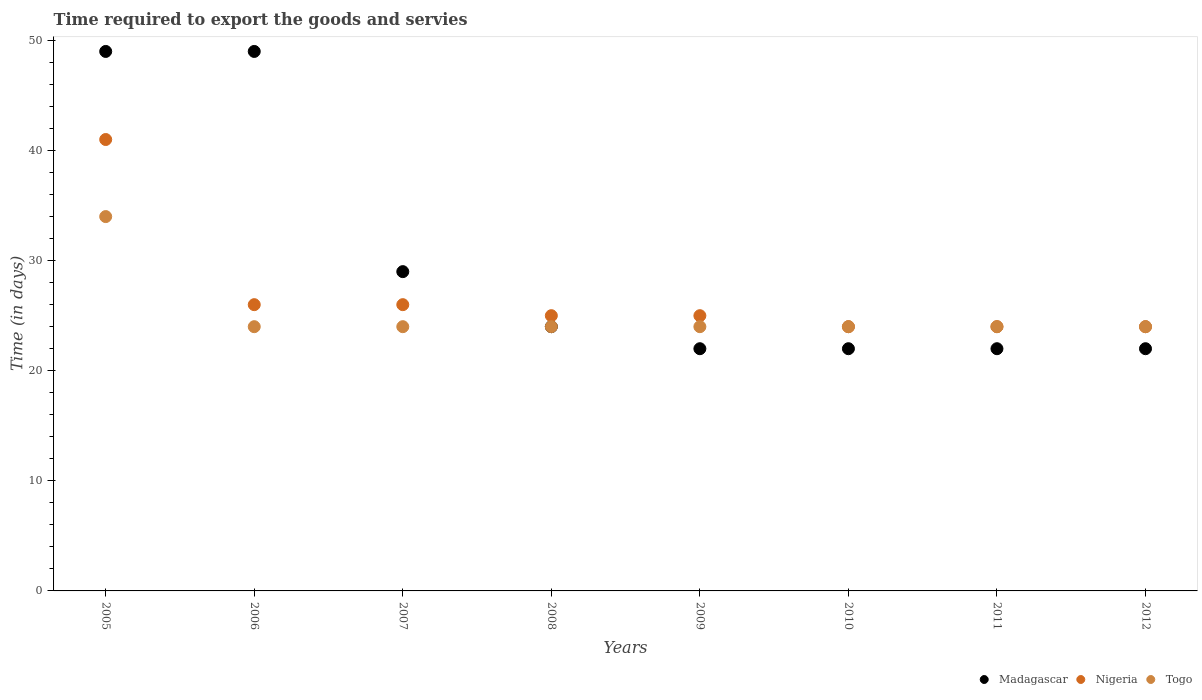How many different coloured dotlines are there?
Your answer should be very brief. 3. Is the number of dotlines equal to the number of legend labels?
Make the answer very short. Yes. What is the number of days required to export the goods and services in Togo in 2009?
Make the answer very short. 24. Across all years, what is the minimum number of days required to export the goods and services in Madagascar?
Give a very brief answer. 22. In which year was the number of days required to export the goods and services in Madagascar maximum?
Make the answer very short. 2005. In which year was the number of days required to export the goods and services in Nigeria minimum?
Offer a terse response. 2010. What is the total number of days required to export the goods and services in Togo in the graph?
Give a very brief answer. 202. What is the difference between the number of days required to export the goods and services in Nigeria in 2005 and that in 2008?
Give a very brief answer. 16. What is the average number of days required to export the goods and services in Madagascar per year?
Offer a very short reply. 29.88. Is the difference between the number of days required to export the goods and services in Nigeria in 2009 and 2011 greater than the difference between the number of days required to export the goods and services in Togo in 2009 and 2011?
Your answer should be compact. Yes. What is the difference between the highest and the second highest number of days required to export the goods and services in Madagascar?
Your answer should be compact. 0. What is the difference between the highest and the lowest number of days required to export the goods and services in Togo?
Offer a terse response. 10. In how many years, is the number of days required to export the goods and services in Nigeria greater than the average number of days required to export the goods and services in Nigeria taken over all years?
Your answer should be compact. 1. Is the sum of the number of days required to export the goods and services in Togo in 2006 and 2010 greater than the maximum number of days required to export the goods and services in Madagascar across all years?
Keep it short and to the point. No. Is it the case that in every year, the sum of the number of days required to export the goods and services in Togo and number of days required to export the goods and services in Nigeria  is greater than the number of days required to export the goods and services in Madagascar?
Offer a very short reply. Yes. Is the number of days required to export the goods and services in Nigeria strictly less than the number of days required to export the goods and services in Madagascar over the years?
Your response must be concise. No. How many years are there in the graph?
Make the answer very short. 8. Are the values on the major ticks of Y-axis written in scientific E-notation?
Offer a terse response. No. Does the graph contain grids?
Make the answer very short. No. What is the title of the graph?
Offer a terse response. Time required to export the goods and servies. What is the label or title of the Y-axis?
Keep it short and to the point. Time (in days). What is the Time (in days) in Nigeria in 2005?
Your response must be concise. 41. What is the Time (in days) of Togo in 2005?
Your answer should be compact. 34. What is the Time (in days) in Madagascar in 2006?
Offer a terse response. 49. What is the Time (in days) of Nigeria in 2006?
Your answer should be very brief. 26. What is the Time (in days) of Togo in 2006?
Provide a short and direct response. 24. What is the Time (in days) of Madagascar in 2007?
Your response must be concise. 29. What is the Time (in days) in Nigeria in 2007?
Make the answer very short. 26. What is the Time (in days) in Madagascar in 2008?
Ensure brevity in your answer.  24. What is the Time (in days) in Nigeria in 2008?
Ensure brevity in your answer.  25. What is the Time (in days) in Togo in 2008?
Your response must be concise. 24. What is the Time (in days) in Nigeria in 2010?
Offer a terse response. 24. What is the Time (in days) in Togo in 2010?
Offer a very short reply. 24. What is the Time (in days) in Madagascar in 2011?
Offer a very short reply. 22. What is the Time (in days) in Togo in 2012?
Provide a succinct answer. 24. Across all years, what is the maximum Time (in days) of Madagascar?
Your answer should be compact. 49. Across all years, what is the maximum Time (in days) in Nigeria?
Your response must be concise. 41. Across all years, what is the maximum Time (in days) in Togo?
Offer a very short reply. 34. Across all years, what is the minimum Time (in days) in Togo?
Your response must be concise. 24. What is the total Time (in days) in Madagascar in the graph?
Give a very brief answer. 239. What is the total Time (in days) in Nigeria in the graph?
Your response must be concise. 215. What is the total Time (in days) of Togo in the graph?
Ensure brevity in your answer.  202. What is the difference between the Time (in days) in Madagascar in 2005 and that in 2006?
Keep it short and to the point. 0. What is the difference between the Time (in days) of Nigeria in 2005 and that in 2006?
Your response must be concise. 15. What is the difference between the Time (in days) of Togo in 2005 and that in 2007?
Ensure brevity in your answer.  10. What is the difference between the Time (in days) in Nigeria in 2005 and that in 2009?
Provide a short and direct response. 16. What is the difference between the Time (in days) of Togo in 2005 and that in 2010?
Offer a terse response. 10. What is the difference between the Time (in days) in Madagascar in 2005 and that in 2011?
Ensure brevity in your answer.  27. What is the difference between the Time (in days) in Nigeria in 2005 and that in 2011?
Make the answer very short. 17. What is the difference between the Time (in days) in Madagascar in 2005 and that in 2012?
Provide a succinct answer. 27. What is the difference between the Time (in days) of Togo in 2005 and that in 2012?
Provide a succinct answer. 10. What is the difference between the Time (in days) of Madagascar in 2006 and that in 2007?
Ensure brevity in your answer.  20. What is the difference between the Time (in days) in Togo in 2006 and that in 2008?
Keep it short and to the point. 0. What is the difference between the Time (in days) of Nigeria in 2006 and that in 2009?
Keep it short and to the point. 1. What is the difference between the Time (in days) of Togo in 2006 and that in 2009?
Offer a very short reply. 0. What is the difference between the Time (in days) of Togo in 2006 and that in 2010?
Offer a very short reply. 0. What is the difference between the Time (in days) of Madagascar in 2006 and that in 2011?
Provide a succinct answer. 27. What is the difference between the Time (in days) in Nigeria in 2006 and that in 2011?
Give a very brief answer. 2. What is the difference between the Time (in days) in Madagascar in 2006 and that in 2012?
Keep it short and to the point. 27. What is the difference between the Time (in days) of Nigeria in 2007 and that in 2008?
Provide a short and direct response. 1. What is the difference between the Time (in days) of Togo in 2007 and that in 2008?
Keep it short and to the point. 0. What is the difference between the Time (in days) of Madagascar in 2007 and that in 2011?
Keep it short and to the point. 7. What is the difference between the Time (in days) of Togo in 2007 and that in 2011?
Your answer should be very brief. 0. What is the difference between the Time (in days) of Nigeria in 2007 and that in 2012?
Ensure brevity in your answer.  2. What is the difference between the Time (in days) in Madagascar in 2008 and that in 2009?
Keep it short and to the point. 2. What is the difference between the Time (in days) in Togo in 2008 and that in 2012?
Offer a very short reply. 0. What is the difference between the Time (in days) of Madagascar in 2009 and that in 2010?
Ensure brevity in your answer.  0. What is the difference between the Time (in days) of Togo in 2009 and that in 2010?
Offer a terse response. 0. What is the difference between the Time (in days) in Madagascar in 2009 and that in 2012?
Ensure brevity in your answer.  0. What is the difference between the Time (in days) in Togo in 2009 and that in 2012?
Provide a short and direct response. 0. What is the difference between the Time (in days) of Madagascar in 2010 and that in 2011?
Your response must be concise. 0. What is the difference between the Time (in days) in Nigeria in 2010 and that in 2011?
Your answer should be compact. 0. What is the difference between the Time (in days) of Togo in 2010 and that in 2011?
Offer a terse response. 0. What is the difference between the Time (in days) of Nigeria in 2010 and that in 2012?
Keep it short and to the point. 0. What is the difference between the Time (in days) of Madagascar in 2011 and that in 2012?
Your response must be concise. 0. What is the difference between the Time (in days) in Nigeria in 2011 and that in 2012?
Your answer should be very brief. 0. What is the difference between the Time (in days) of Togo in 2011 and that in 2012?
Ensure brevity in your answer.  0. What is the difference between the Time (in days) in Madagascar in 2005 and the Time (in days) in Nigeria in 2006?
Provide a succinct answer. 23. What is the difference between the Time (in days) of Nigeria in 2005 and the Time (in days) of Togo in 2006?
Provide a short and direct response. 17. What is the difference between the Time (in days) in Nigeria in 2005 and the Time (in days) in Togo in 2007?
Keep it short and to the point. 17. What is the difference between the Time (in days) in Madagascar in 2005 and the Time (in days) in Nigeria in 2008?
Keep it short and to the point. 24. What is the difference between the Time (in days) in Madagascar in 2005 and the Time (in days) in Togo in 2008?
Make the answer very short. 25. What is the difference between the Time (in days) of Madagascar in 2005 and the Time (in days) of Togo in 2009?
Your answer should be very brief. 25. What is the difference between the Time (in days) of Madagascar in 2005 and the Time (in days) of Nigeria in 2010?
Your response must be concise. 25. What is the difference between the Time (in days) of Madagascar in 2005 and the Time (in days) of Togo in 2010?
Provide a short and direct response. 25. What is the difference between the Time (in days) in Madagascar in 2005 and the Time (in days) in Togo in 2011?
Ensure brevity in your answer.  25. What is the difference between the Time (in days) of Madagascar in 2006 and the Time (in days) of Nigeria in 2007?
Offer a terse response. 23. What is the difference between the Time (in days) of Madagascar in 2006 and the Time (in days) of Togo in 2007?
Give a very brief answer. 25. What is the difference between the Time (in days) in Madagascar in 2006 and the Time (in days) in Nigeria in 2008?
Ensure brevity in your answer.  24. What is the difference between the Time (in days) in Nigeria in 2006 and the Time (in days) in Togo in 2009?
Give a very brief answer. 2. What is the difference between the Time (in days) in Madagascar in 2006 and the Time (in days) in Nigeria in 2010?
Make the answer very short. 25. What is the difference between the Time (in days) in Nigeria in 2006 and the Time (in days) in Togo in 2010?
Offer a very short reply. 2. What is the difference between the Time (in days) in Madagascar in 2006 and the Time (in days) in Nigeria in 2011?
Make the answer very short. 25. What is the difference between the Time (in days) in Madagascar in 2006 and the Time (in days) in Togo in 2012?
Make the answer very short. 25. What is the difference between the Time (in days) of Madagascar in 2007 and the Time (in days) of Nigeria in 2008?
Keep it short and to the point. 4. What is the difference between the Time (in days) in Nigeria in 2007 and the Time (in days) in Togo in 2008?
Give a very brief answer. 2. What is the difference between the Time (in days) in Madagascar in 2007 and the Time (in days) in Nigeria in 2009?
Keep it short and to the point. 4. What is the difference between the Time (in days) of Madagascar in 2007 and the Time (in days) of Togo in 2009?
Offer a very short reply. 5. What is the difference between the Time (in days) of Nigeria in 2007 and the Time (in days) of Togo in 2009?
Keep it short and to the point. 2. What is the difference between the Time (in days) of Madagascar in 2007 and the Time (in days) of Nigeria in 2010?
Give a very brief answer. 5. What is the difference between the Time (in days) of Madagascar in 2007 and the Time (in days) of Togo in 2010?
Your response must be concise. 5. What is the difference between the Time (in days) in Nigeria in 2007 and the Time (in days) in Togo in 2011?
Provide a short and direct response. 2. What is the difference between the Time (in days) of Madagascar in 2007 and the Time (in days) of Nigeria in 2012?
Your answer should be very brief. 5. What is the difference between the Time (in days) of Madagascar in 2007 and the Time (in days) of Togo in 2012?
Your answer should be compact. 5. What is the difference between the Time (in days) of Madagascar in 2008 and the Time (in days) of Nigeria in 2009?
Keep it short and to the point. -1. What is the difference between the Time (in days) of Nigeria in 2008 and the Time (in days) of Togo in 2009?
Ensure brevity in your answer.  1. What is the difference between the Time (in days) in Madagascar in 2008 and the Time (in days) in Nigeria in 2010?
Give a very brief answer. 0. What is the difference between the Time (in days) of Madagascar in 2008 and the Time (in days) of Togo in 2010?
Give a very brief answer. 0. What is the difference between the Time (in days) in Madagascar in 2008 and the Time (in days) in Nigeria in 2011?
Provide a short and direct response. 0. What is the difference between the Time (in days) in Madagascar in 2008 and the Time (in days) in Togo in 2011?
Your response must be concise. 0. What is the difference between the Time (in days) of Nigeria in 2008 and the Time (in days) of Togo in 2011?
Offer a very short reply. 1. What is the difference between the Time (in days) of Madagascar in 2008 and the Time (in days) of Nigeria in 2012?
Make the answer very short. 0. What is the difference between the Time (in days) of Madagascar in 2008 and the Time (in days) of Togo in 2012?
Offer a very short reply. 0. What is the difference between the Time (in days) of Madagascar in 2009 and the Time (in days) of Nigeria in 2010?
Provide a short and direct response. -2. What is the difference between the Time (in days) of Madagascar in 2009 and the Time (in days) of Togo in 2010?
Your answer should be very brief. -2. What is the difference between the Time (in days) of Nigeria in 2009 and the Time (in days) of Togo in 2010?
Offer a terse response. 1. What is the difference between the Time (in days) of Madagascar in 2009 and the Time (in days) of Togo in 2011?
Offer a terse response. -2. What is the difference between the Time (in days) in Madagascar in 2010 and the Time (in days) in Nigeria in 2011?
Offer a terse response. -2. What is the difference between the Time (in days) of Madagascar in 2010 and the Time (in days) of Togo in 2011?
Ensure brevity in your answer.  -2. What is the difference between the Time (in days) in Nigeria in 2010 and the Time (in days) in Togo in 2011?
Ensure brevity in your answer.  0. What is the difference between the Time (in days) of Madagascar in 2011 and the Time (in days) of Nigeria in 2012?
Your answer should be compact. -2. What is the average Time (in days) of Madagascar per year?
Your answer should be compact. 29.88. What is the average Time (in days) of Nigeria per year?
Your answer should be very brief. 26.88. What is the average Time (in days) in Togo per year?
Keep it short and to the point. 25.25. In the year 2005, what is the difference between the Time (in days) of Nigeria and Time (in days) of Togo?
Your answer should be very brief. 7. In the year 2006, what is the difference between the Time (in days) in Madagascar and Time (in days) in Nigeria?
Keep it short and to the point. 23. In the year 2006, what is the difference between the Time (in days) in Madagascar and Time (in days) in Togo?
Your answer should be very brief. 25. In the year 2008, what is the difference between the Time (in days) of Madagascar and Time (in days) of Togo?
Your response must be concise. 0. In the year 2008, what is the difference between the Time (in days) of Nigeria and Time (in days) of Togo?
Keep it short and to the point. 1. In the year 2009, what is the difference between the Time (in days) in Madagascar and Time (in days) in Nigeria?
Your answer should be compact. -3. In the year 2009, what is the difference between the Time (in days) of Madagascar and Time (in days) of Togo?
Your answer should be compact. -2. In the year 2009, what is the difference between the Time (in days) of Nigeria and Time (in days) of Togo?
Keep it short and to the point. 1. In the year 2010, what is the difference between the Time (in days) of Madagascar and Time (in days) of Nigeria?
Your answer should be compact. -2. In the year 2010, what is the difference between the Time (in days) in Madagascar and Time (in days) in Togo?
Your answer should be compact. -2. In the year 2011, what is the difference between the Time (in days) in Madagascar and Time (in days) in Nigeria?
Give a very brief answer. -2. In the year 2011, what is the difference between the Time (in days) of Madagascar and Time (in days) of Togo?
Provide a succinct answer. -2. In the year 2011, what is the difference between the Time (in days) of Nigeria and Time (in days) of Togo?
Make the answer very short. 0. What is the ratio of the Time (in days) in Nigeria in 2005 to that in 2006?
Offer a very short reply. 1.58. What is the ratio of the Time (in days) in Togo in 2005 to that in 2006?
Keep it short and to the point. 1.42. What is the ratio of the Time (in days) of Madagascar in 2005 to that in 2007?
Offer a very short reply. 1.69. What is the ratio of the Time (in days) of Nigeria in 2005 to that in 2007?
Provide a short and direct response. 1.58. What is the ratio of the Time (in days) of Togo in 2005 to that in 2007?
Offer a very short reply. 1.42. What is the ratio of the Time (in days) in Madagascar in 2005 to that in 2008?
Provide a short and direct response. 2.04. What is the ratio of the Time (in days) of Nigeria in 2005 to that in 2008?
Make the answer very short. 1.64. What is the ratio of the Time (in days) in Togo in 2005 to that in 2008?
Give a very brief answer. 1.42. What is the ratio of the Time (in days) in Madagascar in 2005 to that in 2009?
Provide a short and direct response. 2.23. What is the ratio of the Time (in days) in Nigeria in 2005 to that in 2009?
Your answer should be very brief. 1.64. What is the ratio of the Time (in days) of Togo in 2005 to that in 2009?
Keep it short and to the point. 1.42. What is the ratio of the Time (in days) in Madagascar in 2005 to that in 2010?
Keep it short and to the point. 2.23. What is the ratio of the Time (in days) in Nigeria in 2005 to that in 2010?
Keep it short and to the point. 1.71. What is the ratio of the Time (in days) in Togo in 2005 to that in 2010?
Offer a very short reply. 1.42. What is the ratio of the Time (in days) in Madagascar in 2005 to that in 2011?
Provide a succinct answer. 2.23. What is the ratio of the Time (in days) in Nigeria in 2005 to that in 2011?
Offer a very short reply. 1.71. What is the ratio of the Time (in days) in Togo in 2005 to that in 2011?
Provide a succinct answer. 1.42. What is the ratio of the Time (in days) in Madagascar in 2005 to that in 2012?
Offer a very short reply. 2.23. What is the ratio of the Time (in days) of Nigeria in 2005 to that in 2012?
Ensure brevity in your answer.  1.71. What is the ratio of the Time (in days) in Togo in 2005 to that in 2012?
Provide a succinct answer. 1.42. What is the ratio of the Time (in days) of Madagascar in 2006 to that in 2007?
Make the answer very short. 1.69. What is the ratio of the Time (in days) of Nigeria in 2006 to that in 2007?
Your answer should be very brief. 1. What is the ratio of the Time (in days) in Madagascar in 2006 to that in 2008?
Offer a very short reply. 2.04. What is the ratio of the Time (in days) in Togo in 2006 to that in 2008?
Offer a very short reply. 1. What is the ratio of the Time (in days) of Madagascar in 2006 to that in 2009?
Offer a terse response. 2.23. What is the ratio of the Time (in days) in Nigeria in 2006 to that in 2009?
Ensure brevity in your answer.  1.04. What is the ratio of the Time (in days) of Togo in 2006 to that in 2009?
Ensure brevity in your answer.  1. What is the ratio of the Time (in days) in Madagascar in 2006 to that in 2010?
Provide a succinct answer. 2.23. What is the ratio of the Time (in days) of Nigeria in 2006 to that in 2010?
Keep it short and to the point. 1.08. What is the ratio of the Time (in days) in Togo in 2006 to that in 2010?
Make the answer very short. 1. What is the ratio of the Time (in days) of Madagascar in 2006 to that in 2011?
Give a very brief answer. 2.23. What is the ratio of the Time (in days) of Madagascar in 2006 to that in 2012?
Give a very brief answer. 2.23. What is the ratio of the Time (in days) in Nigeria in 2006 to that in 2012?
Give a very brief answer. 1.08. What is the ratio of the Time (in days) of Togo in 2006 to that in 2012?
Offer a very short reply. 1. What is the ratio of the Time (in days) in Madagascar in 2007 to that in 2008?
Offer a very short reply. 1.21. What is the ratio of the Time (in days) in Nigeria in 2007 to that in 2008?
Your answer should be compact. 1.04. What is the ratio of the Time (in days) in Togo in 2007 to that in 2008?
Your response must be concise. 1. What is the ratio of the Time (in days) of Madagascar in 2007 to that in 2009?
Offer a terse response. 1.32. What is the ratio of the Time (in days) of Togo in 2007 to that in 2009?
Make the answer very short. 1. What is the ratio of the Time (in days) of Madagascar in 2007 to that in 2010?
Provide a short and direct response. 1.32. What is the ratio of the Time (in days) in Nigeria in 2007 to that in 2010?
Give a very brief answer. 1.08. What is the ratio of the Time (in days) of Madagascar in 2007 to that in 2011?
Provide a succinct answer. 1.32. What is the ratio of the Time (in days) in Nigeria in 2007 to that in 2011?
Your answer should be compact. 1.08. What is the ratio of the Time (in days) of Togo in 2007 to that in 2011?
Your answer should be compact. 1. What is the ratio of the Time (in days) of Madagascar in 2007 to that in 2012?
Your answer should be compact. 1.32. What is the ratio of the Time (in days) in Nigeria in 2007 to that in 2012?
Your answer should be very brief. 1.08. What is the ratio of the Time (in days) in Togo in 2008 to that in 2009?
Ensure brevity in your answer.  1. What is the ratio of the Time (in days) of Madagascar in 2008 to that in 2010?
Your answer should be very brief. 1.09. What is the ratio of the Time (in days) in Nigeria in 2008 to that in 2010?
Give a very brief answer. 1.04. What is the ratio of the Time (in days) in Togo in 2008 to that in 2010?
Offer a terse response. 1. What is the ratio of the Time (in days) of Nigeria in 2008 to that in 2011?
Your answer should be very brief. 1.04. What is the ratio of the Time (in days) in Nigeria in 2008 to that in 2012?
Keep it short and to the point. 1.04. What is the ratio of the Time (in days) in Madagascar in 2009 to that in 2010?
Provide a succinct answer. 1. What is the ratio of the Time (in days) of Nigeria in 2009 to that in 2010?
Offer a terse response. 1.04. What is the ratio of the Time (in days) of Togo in 2009 to that in 2010?
Ensure brevity in your answer.  1. What is the ratio of the Time (in days) in Nigeria in 2009 to that in 2011?
Make the answer very short. 1.04. What is the ratio of the Time (in days) of Togo in 2009 to that in 2011?
Ensure brevity in your answer.  1. What is the ratio of the Time (in days) in Madagascar in 2009 to that in 2012?
Your response must be concise. 1. What is the ratio of the Time (in days) in Nigeria in 2009 to that in 2012?
Make the answer very short. 1.04. What is the ratio of the Time (in days) in Madagascar in 2010 to that in 2011?
Give a very brief answer. 1. What is the ratio of the Time (in days) of Togo in 2010 to that in 2011?
Offer a very short reply. 1. What is the ratio of the Time (in days) of Madagascar in 2010 to that in 2012?
Give a very brief answer. 1. What is the ratio of the Time (in days) of Togo in 2010 to that in 2012?
Your answer should be very brief. 1. What is the ratio of the Time (in days) in Nigeria in 2011 to that in 2012?
Ensure brevity in your answer.  1. What is the difference between the highest and the second highest Time (in days) of Nigeria?
Offer a terse response. 15. What is the difference between the highest and the lowest Time (in days) in Nigeria?
Offer a very short reply. 17. What is the difference between the highest and the lowest Time (in days) of Togo?
Your response must be concise. 10. 